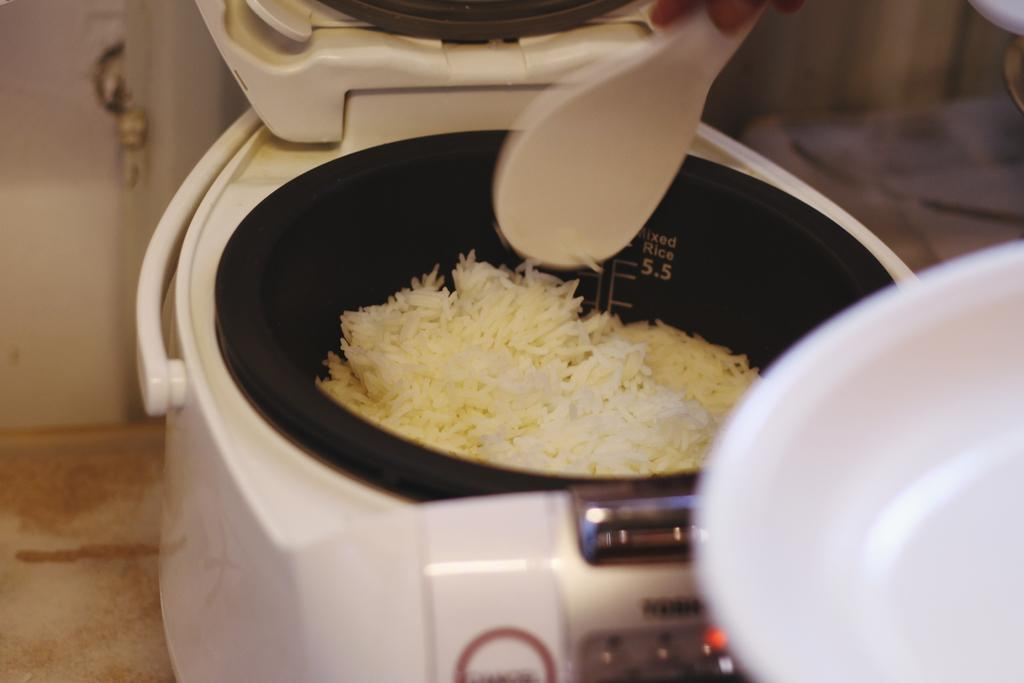<image>
Summarize the visual content of the image. A rice cooker is getting some white rice spooned out of it with a label that reads cooked rice 5.5 on the inside of it. 